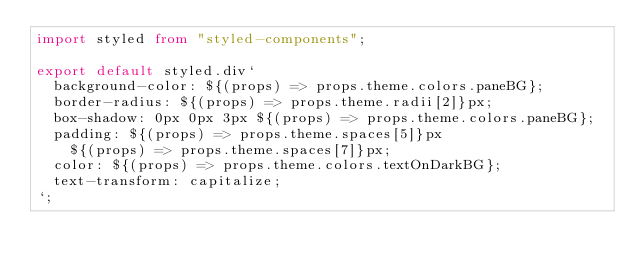<code> <loc_0><loc_0><loc_500><loc_500><_TypeScript_>import styled from "styled-components";

export default styled.div`
  background-color: ${(props) => props.theme.colors.paneBG};
  border-radius: ${(props) => props.theme.radii[2]}px;
  box-shadow: 0px 0px 3px ${(props) => props.theme.colors.paneBG};
  padding: ${(props) => props.theme.spaces[5]}px
    ${(props) => props.theme.spaces[7]}px;
  color: ${(props) => props.theme.colors.textOnDarkBG};
  text-transform: capitalize;
`;
</code> 